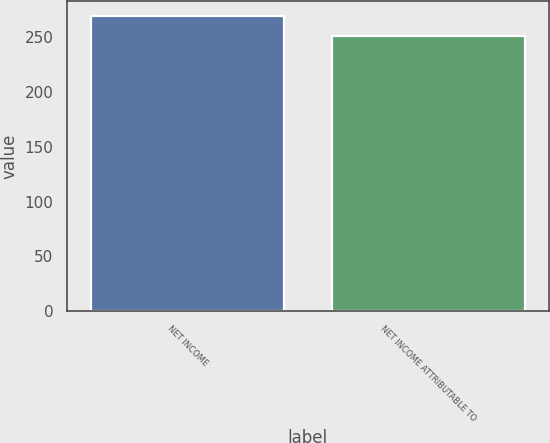Convert chart to OTSL. <chart><loc_0><loc_0><loc_500><loc_500><bar_chart><fcel>NET INCOME<fcel>NET INCOME ATTRIBUTABLE TO<nl><fcel>269<fcel>251<nl></chart> 